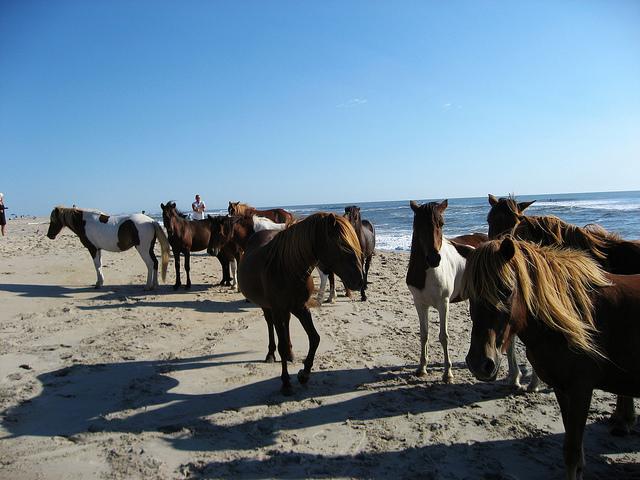Why is the horse on the beach?
Be succinct. To cool off. How many horses are in the picture?
Concise answer only. 9. How many animals can be seen?
Answer briefly. 9. How many four legs animals on this picture?
Answer briefly. 8. Are the horses scared of the water?
Write a very short answer. No. Where are these horses?
Concise answer only. Beach. What are the horses walking on?
Write a very short answer. Sand. What type of animals are present?
Be succinct. Horses. Is the sky clear?
Give a very brief answer. Yes. 